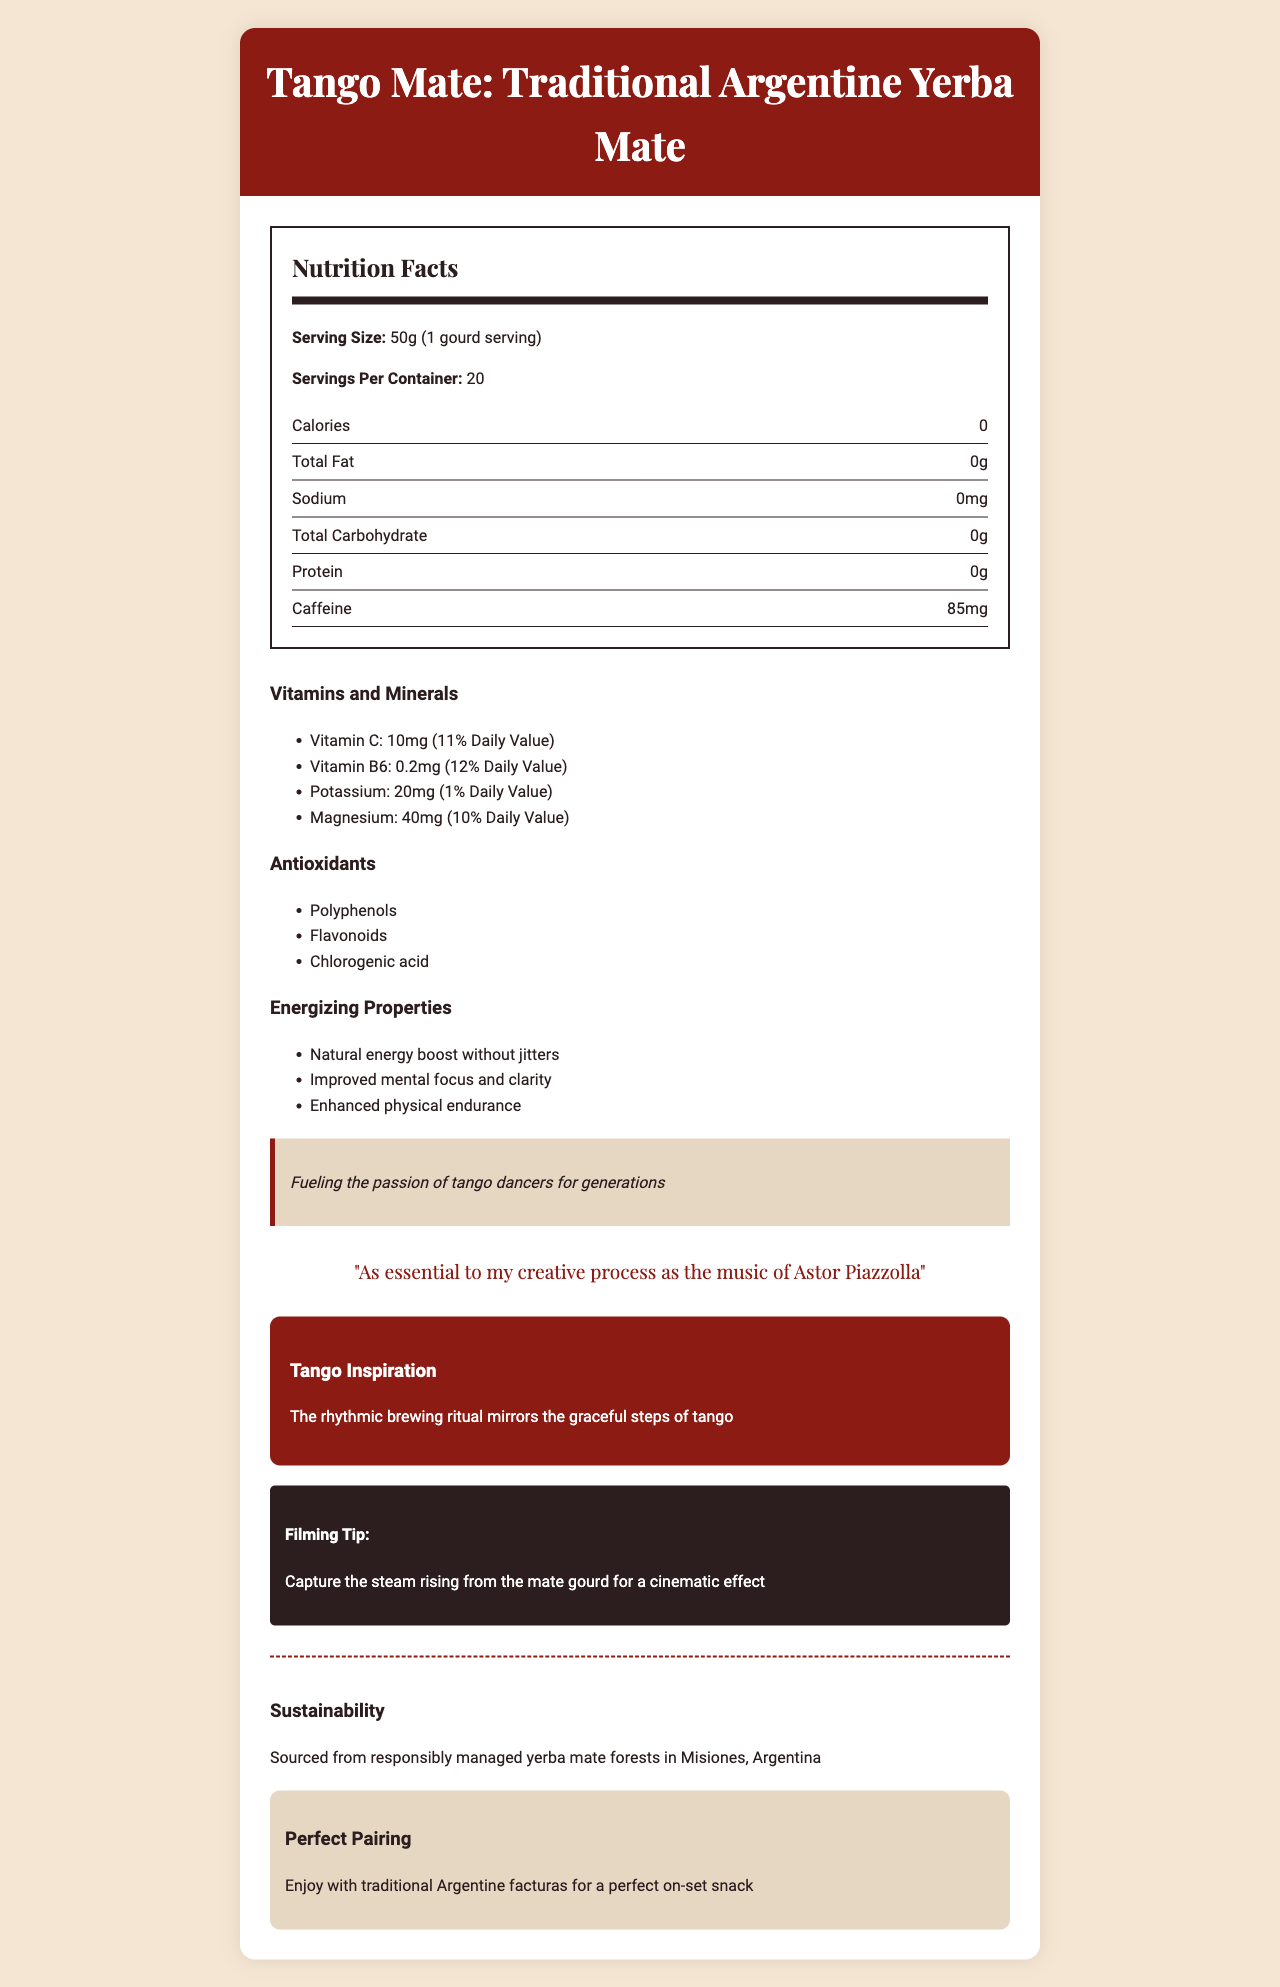what is the serving size for Tango Mate? The document lists the serving size in the Nutrition Facts section as 50g, which is equivalent to 1 gourd serving.
Answer: 50g (1 gourd serving) how many servings are in each container of Tango Mate? The document states that there are 20 servings per container.
Answer: 20 how many calories does one serving of Tango Mate contain? The Nutrition Facts section of the document shows that one serving of Tango Mate contains 0 calories.
Answer: 0 what are some of the antioxidants found in Tango Mate? The Antioxidants section of the document lists Polyphenols, Flavonoids, and Chlorogenic acid.
Answer: Polyphenols, Flavonoids, Chlorogenic acid how much caffeine is in one serving of Tango Mate? The Nutrition Facts section states that there are 85mg of caffeine in one serving of Tango Mate.
Answer: 85mg which vitamin is present in greater quantity in Tango Mate? A. Vitamin C B. Vitamin B6 C. Vitamin D The document lists Vitamin C at 10mg (11% Daily Value) and Vitamin B6 at 0.2mg (12% Daily Value), with no mention of Vitamin D.
Answer: A which mineral in Tango Mate contributes to 10% of the daily value? A. Calcium B. Potassium C. Magnesium D. Iron The document mentions that Magnesium contributes to 10% of the Daily Value, while Potassium contributes to 1%.
Answer: C is there any fat contained in one serving of Tango Mate? The Nutrition Facts indicate that Tango Mate contains 0g of total fat.
Answer: No describe the main idea of the document. The detailed description includes nutritional components like calories, fat content, caffeine, vitamins, and minerals, along with cultural notes and information pertinent to filmmaking and sustainability.
Answer: The document provides detailed nutrition facts for Tango Mate, a traditional Argentine Yerba Mate, highlighting its energizing properties, vitamins, minerals, antioxidants, and cultural significance. It also includes personal notes from a director, filming tips, and sustainability information. what is the branding recommendation for enjoying Tango Mate on-set? The Pairing Recommendation section suggests enjoying Tango Mate with traditional Argentine facturas for a perfect on-set snack.
Answer: Enjoy with traditional Argentine facturas for a perfect on-set snack where is the ingredient sourcing information provided in the document? The Sustainability section of the document mentions that Tango Mate is sourced from responsibly managed yerba mate forests in Misiones, Argentina.
Answer: The Sustainability section can the exact effects of antioxidants in Tango Mate be determined from the document? The document lists the types of antioxidants present (Polyphenols, Flavonoids, Chlorogenic acid) but does not detail their exact effects.
Answer: No what quote does the director use to describe Tango Mate's importance to their creative process? The Director Note section quotes the director saying, "As essential to my creative process as the music of Astor Piazzolla."
Answer: "As essential to my creative process as the music of Astor Piazzolla" 